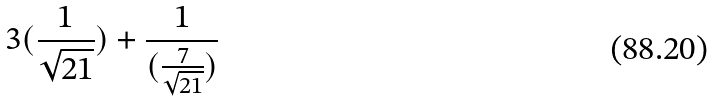Convert formula to latex. <formula><loc_0><loc_0><loc_500><loc_500>3 ( \frac { 1 } { \sqrt { 2 1 } } ) + \frac { 1 } { ( \frac { 7 } { \sqrt { 2 1 } } ) }</formula> 